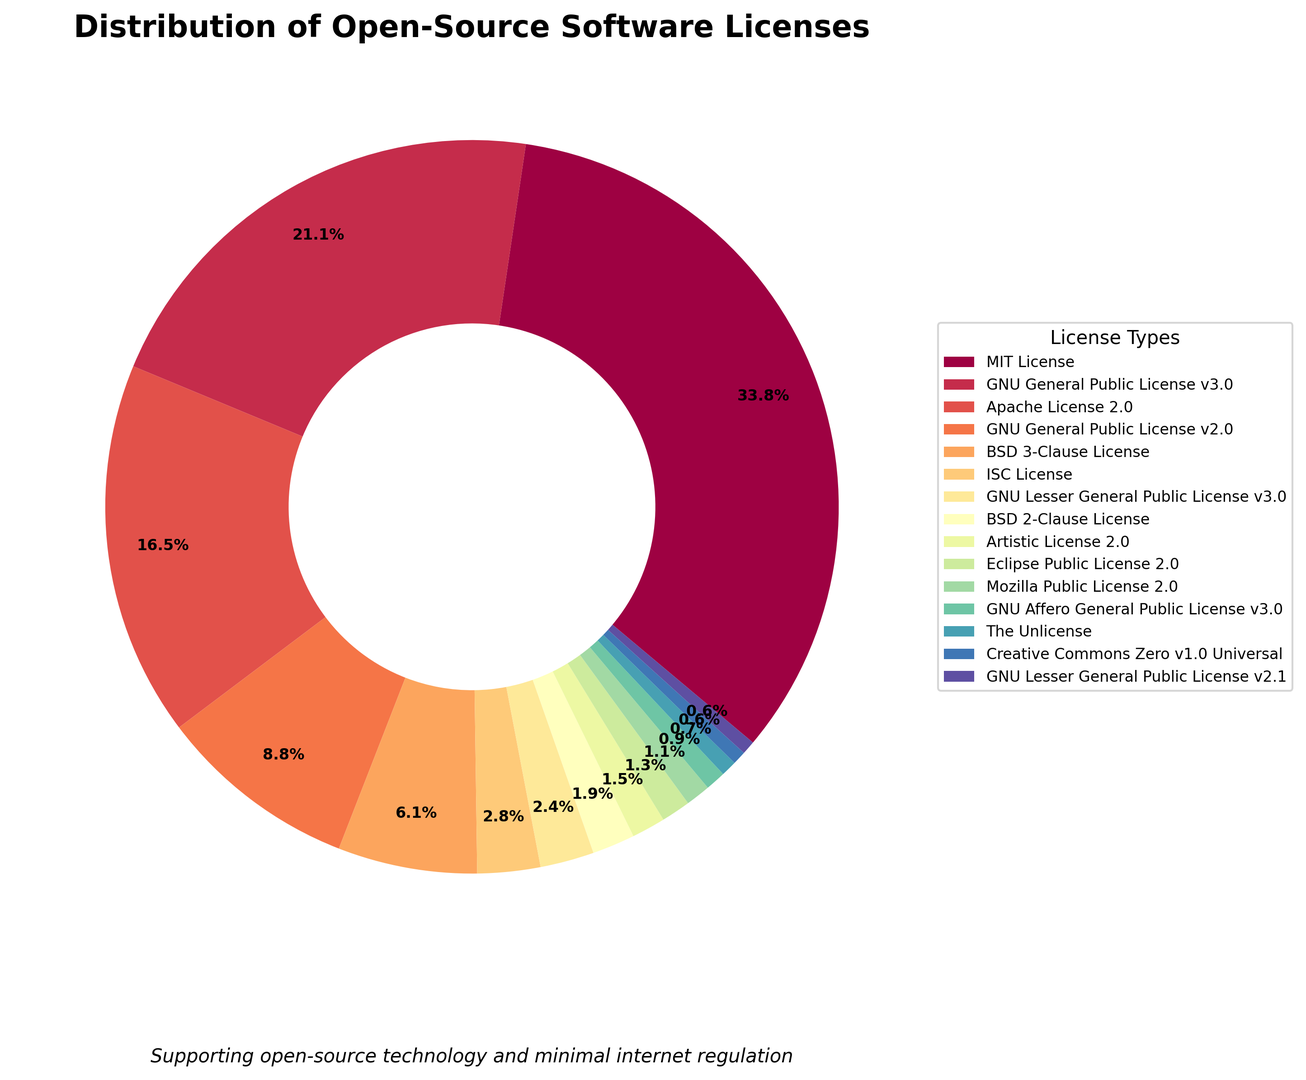What percentage of open-source software licenses are MIT and Apache combined? To find the combined percentage, simply add the individual percentages of MIT and Apache licenses. MIT is 34.1% and Apache is 16.7%. So, 34.1% + 16.7% = 50.8%.
Answer: 50.8% Which open-source license type has the smallest share? To determine the smallest share, look at the figure and identify the license type with the smallest percentage. The smallest share is Creative Commons Zero v1.0 Universal at 0.6%.
Answer: Creative Commons Zero v1.0 Universal How does the share of GNU General Public License v3.0 compare to that of Apache License 2.0? Compare the percentages of the two licenses. The GNU General Public License v3.0 is 21.3% and Apache License 2.0 is 16.7%. Thus, the GNU General Public License v3.0 has a larger share.
Answer: GNU General Public License v3.0 has a larger share What percentage of open-source software licenses are not GNU-related (excluding any GNU licenses)? Exclude all GNU-related licenses (v3.0, v2.0, Lesser v3.0, Affero General Public License v3.0, Lesser General Public License v2.1) and sum the rest. Summing the percentages of non-GNU licenses (34.1 + 16.7 + 6.2 + 2.8 + 1.9 + 1.5 + 1.3 + 1.1 + 0.7 + 0.6) gives a total of 66.9%.
Answer: 66.9% Are there more BSD licenses (3-Clause and 2-Clause) or more Lesser General Public Licenses (v3.0 and v2.1) combined? Add the percentages of the BSD licenses (6.2% for 3-Clause and 1.9% for 2-Clause) and compare them with the combined percentages of the Lesser General Public Licenses (2.4% for v3.0 and 0.6% for v2.1). BSD total is 8.1%; Lesser GPL total is 3.0%. Thus, there are more BSD licenses.
Answer: More BSD licenses Rank the top three licenses by percentage share. Identify the licenses with the three largest percentages in the figure. The top three are MIT License (34.1%), GNU General Public License v3.0 (21.3%), and Apache License 2.0 (16.7%).
Answer: MIT License, GNU General Public License v3.0, Apache License 2.0 What is the median percentage of all the listed license types? To find the median percentage, arrange all percentages in ascending order: 0.6, 0.6, 0.7, 0.9, 1.1, 1.3, 1.5, 1.9, 2.4, 2.8, 6.2, 8.9, 16.7, 21.3, 34.1. The median is the middle value, which is 2.4%.
Answer: 2.4% What is the visual color spectrum used for the MIT License? Identify the color associated with the MIT License segment in the ring chart. The MIT License is represented by the first color in the Spectral color palette, which is typically a shade of red.
Answer: Red 